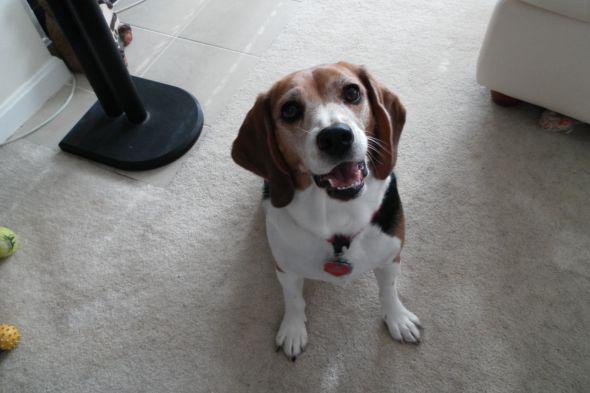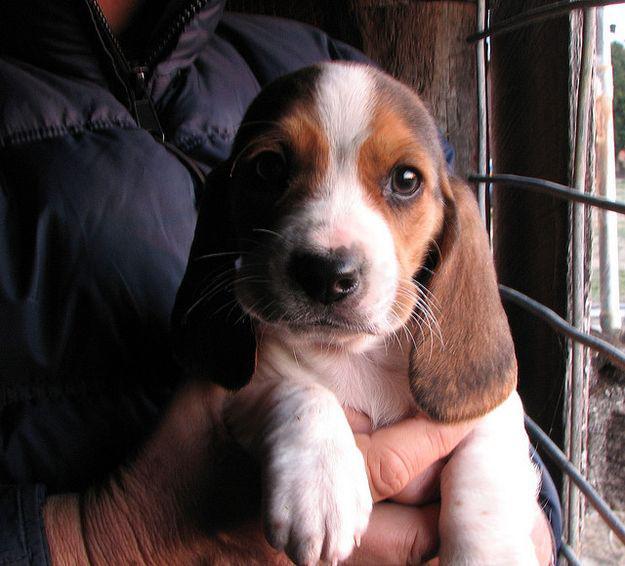The first image is the image on the left, the second image is the image on the right. Examine the images to the left and right. Is the description "The left image contains at least two dogs." accurate? Answer yes or no. No. The first image is the image on the left, the second image is the image on the right. Considering the images on both sides, is "There are no less than three beagle puppies" valid? Answer yes or no. No. 